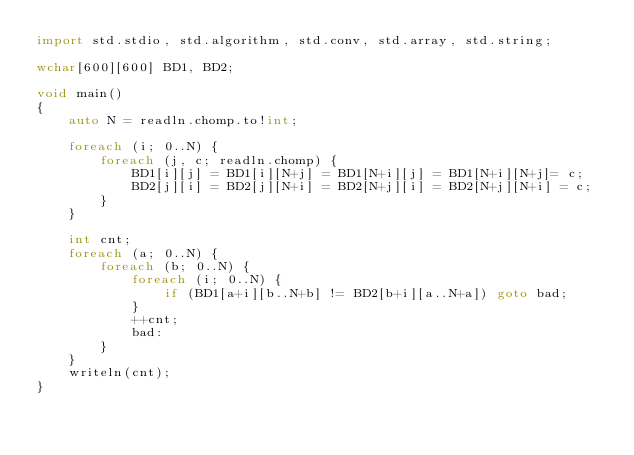<code> <loc_0><loc_0><loc_500><loc_500><_D_>import std.stdio, std.algorithm, std.conv, std.array, std.string;

wchar[600][600] BD1, BD2;

void main()
{
    auto N = readln.chomp.to!int;

    foreach (i; 0..N) {
        foreach (j, c; readln.chomp) {
            BD1[i][j] = BD1[i][N+j] = BD1[N+i][j] = BD1[N+i][N+j]= c;
            BD2[j][i] = BD2[j][N+i] = BD2[N+j][i] = BD2[N+j][N+i] = c;
        }
    }

    int cnt;
    foreach (a; 0..N) {
        foreach (b; 0..N) {
            foreach (i; 0..N) {
                if (BD1[a+i][b..N+b] != BD2[b+i][a..N+a]) goto bad;
            }
            ++cnt;
            bad:
        }
    }
    writeln(cnt);
}</code> 